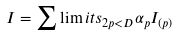Convert formula to latex. <formula><loc_0><loc_0><loc_500><loc_500>I = \sum \lim i t s _ { 2 p < D } \alpha _ { p } I _ { ( p ) }</formula> 